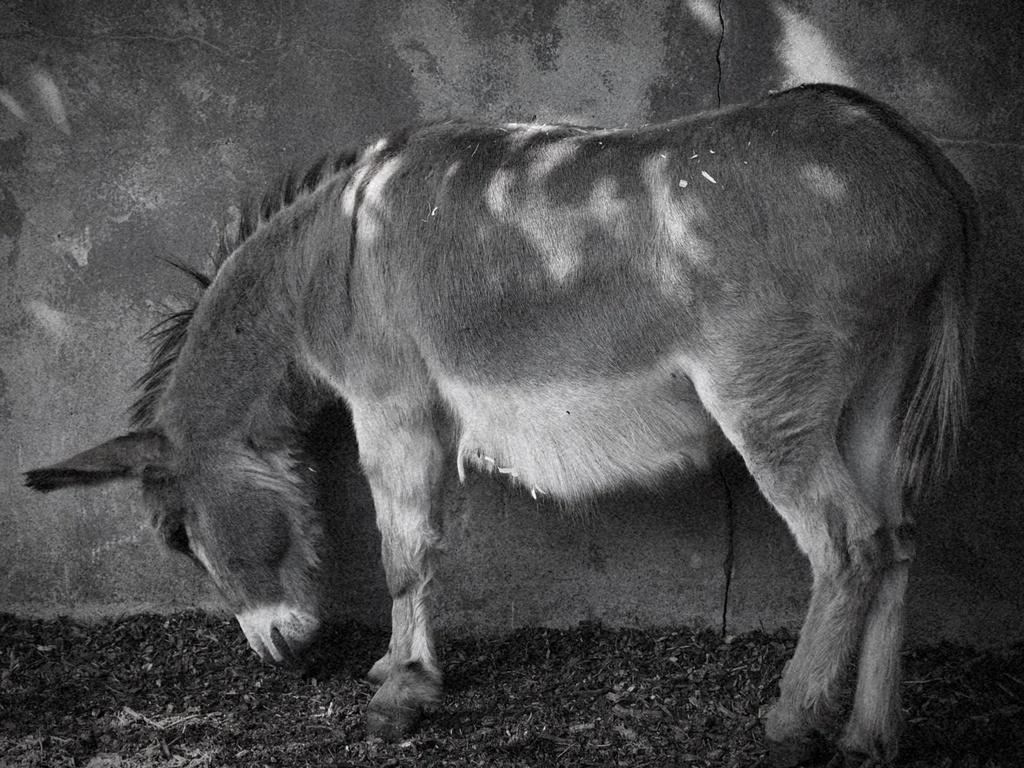What type of animal is depicted in the black and white picture in the image? The image contains a black and white picture of a donkey. What else can be seen in the image besides the donkey? There is a wall visible in the image. What time of day is the donkey moving in the image? The image is a black and white picture, and there is no indication of motion or time of day for the donkey. 